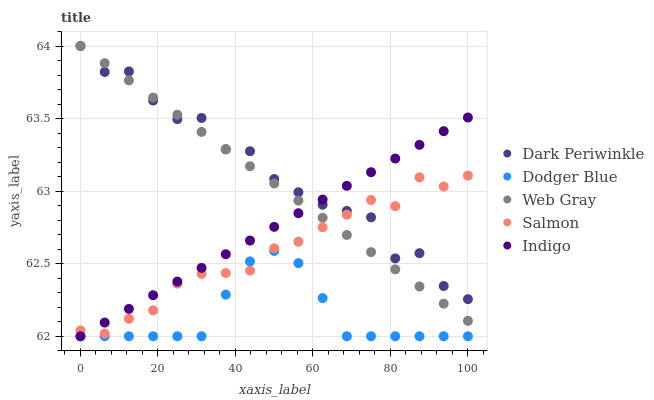Does Dodger Blue have the minimum area under the curve?
Answer yes or no. Yes. Does Dark Periwinkle have the maximum area under the curve?
Answer yes or no. Yes. Does Web Gray have the minimum area under the curve?
Answer yes or no. No. Does Web Gray have the maximum area under the curve?
Answer yes or no. No. Is Indigo the smoothest?
Answer yes or no. Yes. Is Dark Periwinkle the roughest?
Answer yes or no. Yes. Is Web Gray the smoothest?
Answer yes or no. No. Is Web Gray the roughest?
Answer yes or no. No. Does Dodger Blue have the lowest value?
Answer yes or no. Yes. Does Web Gray have the lowest value?
Answer yes or no. No. Does Dark Periwinkle have the highest value?
Answer yes or no. Yes. Does Dodger Blue have the highest value?
Answer yes or no. No. Is Dodger Blue less than Dark Periwinkle?
Answer yes or no. Yes. Is Dark Periwinkle greater than Dodger Blue?
Answer yes or no. Yes. Does Dark Periwinkle intersect Salmon?
Answer yes or no. Yes. Is Dark Periwinkle less than Salmon?
Answer yes or no. No. Is Dark Periwinkle greater than Salmon?
Answer yes or no. No. Does Dodger Blue intersect Dark Periwinkle?
Answer yes or no. No. 